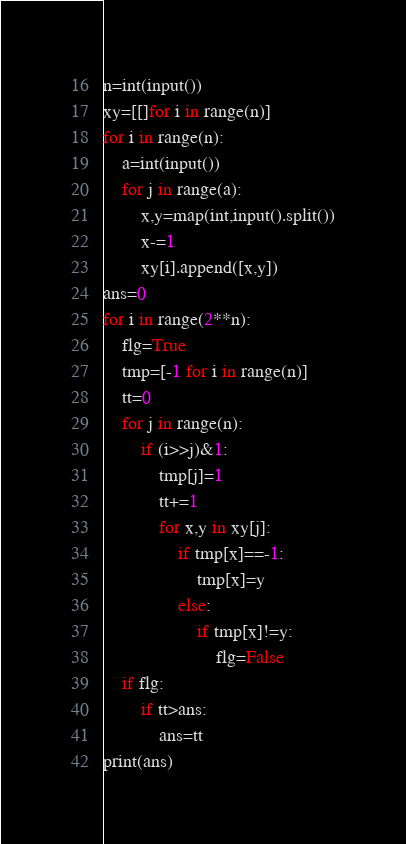Convert code to text. <code><loc_0><loc_0><loc_500><loc_500><_Python_>n=int(input())
xy=[[]for i in range(n)]
for i in range(n):
    a=int(input())
    for j in range(a):
        x,y=map(int,input().split())
        x-=1
        xy[i].append([x,y])
ans=0
for i in range(2**n):
    flg=True
    tmp=[-1 for i in range(n)]
    tt=0
    for j in range(n):
        if (i>>j)&1:
            tmp[j]=1
            tt+=1
            for x,y in xy[j]:
                if tmp[x]==-1:
                    tmp[x]=y
                else: 
                    if tmp[x]!=y:
                        flg=False
    if flg:
        if tt>ans:
            ans=tt
print(ans)</code> 